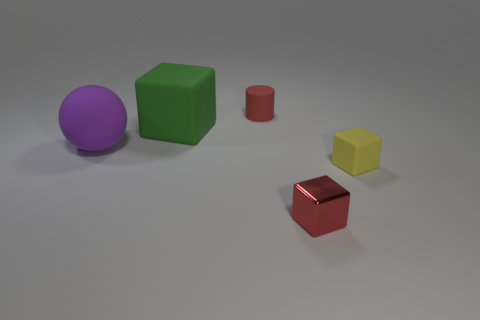What material is the cube to the left of the tiny red thing behind the big thing that is behind the rubber ball?
Your answer should be compact. Rubber. There is a matte thing that is right of the big green matte thing and in front of the green rubber thing; how big is it?
Provide a succinct answer. Small. What number of cylinders are yellow rubber objects or shiny objects?
Keep it short and to the point. 0. The other object that is the same size as the purple rubber thing is what color?
Make the answer very short. Green. Are there any other things that are the same shape as the large purple object?
Your answer should be compact. No. What is the color of the big rubber object that is the same shape as the shiny thing?
Ensure brevity in your answer.  Green. What number of objects are either blue metallic things or matte objects in front of the big block?
Ensure brevity in your answer.  2. Is the number of green blocks that are on the left side of the purple matte sphere less than the number of large green objects?
Your answer should be very brief. Yes. What is the size of the red thing that is behind the rubber cube to the right of the red thing behind the yellow matte thing?
Offer a very short reply. Small. There is a thing that is in front of the big green matte block and behind the small yellow object; what is its color?
Provide a succinct answer. Purple. 